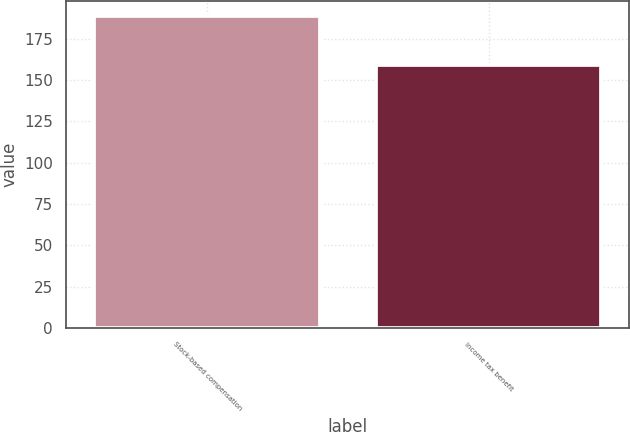<chart> <loc_0><loc_0><loc_500><loc_500><bar_chart><fcel>Stock-based compensation<fcel>Income tax benefit<nl><fcel>188.5<fcel>159<nl></chart> 